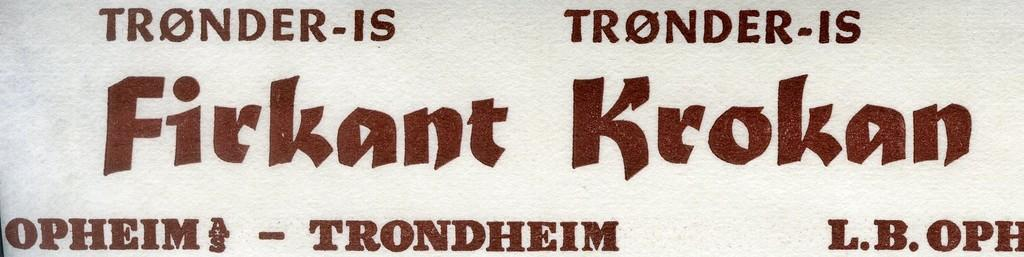<image>
Give a short and clear explanation of the subsequent image. A label that seems to be in norwegian with the word trondheim at the bottom. 